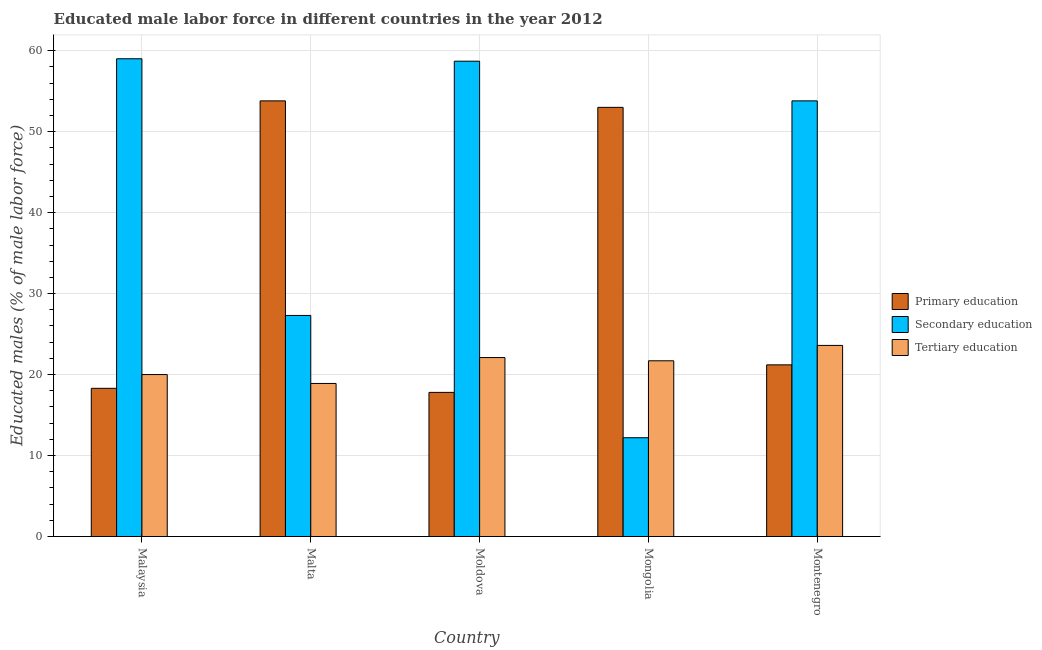How many different coloured bars are there?
Offer a very short reply. 3. How many groups of bars are there?
Give a very brief answer. 5. Are the number of bars per tick equal to the number of legend labels?
Make the answer very short. Yes. Are the number of bars on each tick of the X-axis equal?
Make the answer very short. Yes. How many bars are there on the 5th tick from the left?
Your answer should be compact. 3. What is the label of the 2nd group of bars from the left?
Provide a short and direct response. Malta. In how many cases, is the number of bars for a given country not equal to the number of legend labels?
Your answer should be very brief. 0. What is the percentage of male labor force who received primary education in Malta?
Your answer should be very brief. 53.8. Across all countries, what is the maximum percentage of male labor force who received primary education?
Your answer should be compact. 53.8. Across all countries, what is the minimum percentage of male labor force who received tertiary education?
Offer a very short reply. 18.9. In which country was the percentage of male labor force who received primary education maximum?
Offer a terse response. Malta. In which country was the percentage of male labor force who received tertiary education minimum?
Provide a short and direct response. Malta. What is the total percentage of male labor force who received secondary education in the graph?
Your answer should be compact. 211. What is the difference between the percentage of male labor force who received primary education in Malta and that in Mongolia?
Offer a terse response. 0.8. What is the difference between the percentage of male labor force who received primary education in Montenegro and the percentage of male labor force who received tertiary education in Mongolia?
Keep it short and to the point. -0.5. What is the average percentage of male labor force who received primary education per country?
Provide a succinct answer. 32.82. What is the difference between the percentage of male labor force who received tertiary education and percentage of male labor force who received secondary education in Montenegro?
Offer a very short reply. -30.2. In how many countries, is the percentage of male labor force who received primary education greater than 42 %?
Ensure brevity in your answer.  2. What is the ratio of the percentage of male labor force who received primary education in Moldova to that in Mongolia?
Your response must be concise. 0.34. Is the percentage of male labor force who received primary education in Malta less than that in Mongolia?
Keep it short and to the point. No. Is the difference between the percentage of male labor force who received primary education in Malta and Montenegro greater than the difference between the percentage of male labor force who received secondary education in Malta and Montenegro?
Provide a succinct answer. Yes. What is the difference between the highest and the second highest percentage of male labor force who received secondary education?
Your response must be concise. 0.3. What is the difference between the highest and the lowest percentage of male labor force who received primary education?
Your answer should be compact. 36. In how many countries, is the percentage of male labor force who received primary education greater than the average percentage of male labor force who received primary education taken over all countries?
Your answer should be very brief. 2. What does the 2nd bar from the left in Mongolia represents?
Your answer should be compact. Secondary education. What does the 2nd bar from the right in Mongolia represents?
Offer a terse response. Secondary education. How many countries are there in the graph?
Your answer should be compact. 5. What is the difference between two consecutive major ticks on the Y-axis?
Offer a very short reply. 10. Are the values on the major ticks of Y-axis written in scientific E-notation?
Your answer should be compact. No. Where does the legend appear in the graph?
Offer a very short reply. Center right. How are the legend labels stacked?
Provide a short and direct response. Vertical. What is the title of the graph?
Offer a terse response. Educated male labor force in different countries in the year 2012. What is the label or title of the Y-axis?
Provide a short and direct response. Educated males (% of male labor force). What is the Educated males (% of male labor force) of Primary education in Malaysia?
Make the answer very short. 18.3. What is the Educated males (% of male labor force) of Primary education in Malta?
Offer a terse response. 53.8. What is the Educated males (% of male labor force) of Secondary education in Malta?
Give a very brief answer. 27.3. What is the Educated males (% of male labor force) in Tertiary education in Malta?
Provide a short and direct response. 18.9. What is the Educated males (% of male labor force) in Primary education in Moldova?
Offer a terse response. 17.8. What is the Educated males (% of male labor force) of Secondary education in Moldova?
Offer a very short reply. 58.7. What is the Educated males (% of male labor force) of Tertiary education in Moldova?
Ensure brevity in your answer.  22.1. What is the Educated males (% of male labor force) in Secondary education in Mongolia?
Ensure brevity in your answer.  12.2. What is the Educated males (% of male labor force) of Tertiary education in Mongolia?
Offer a terse response. 21.7. What is the Educated males (% of male labor force) of Primary education in Montenegro?
Offer a very short reply. 21.2. What is the Educated males (% of male labor force) in Secondary education in Montenegro?
Your answer should be very brief. 53.8. What is the Educated males (% of male labor force) in Tertiary education in Montenegro?
Provide a succinct answer. 23.6. Across all countries, what is the maximum Educated males (% of male labor force) in Primary education?
Keep it short and to the point. 53.8. Across all countries, what is the maximum Educated males (% of male labor force) of Tertiary education?
Make the answer very short. 23.6. Across all countries, what is the minimum Educated males (% of male labor force) in Primary education?
Give a very brief answer. 17.8. Across all countries, what is the minimum Educated males (% of male labor force) in Secondary education?
Your response must be concise. 12.2. Across all countries, what is the minimum Educated males (% of male labor force) of Tertiary education?
Ensure brevity in your answer.  18.9. What is the total Educated males (% of male labor force) in Primary education in the graph?
Offer a terse response. 164.1. What is the total Educated males (% of male labor force) of Secondary education in the graph?
Your response must be concise. 211. What is the total Educated males (% of male labor force) of Tertiary education in the graph?
Your response must be concise. 106.3. What is the difference between the Educated males (% of male labor force) in Primary education in Malaysia and that in Malta?
Make the answer very short. -35.5. What is the difference between the Educated males (% of male labor force) of Secondary education in Malaysia and that in Malta?
Keep it short and to the point. 31.7. What is the difference between the Educated males (% of male labor force) of Primary education in Malaysia and that in Moldova?
Offer a very short reply. 0.5. What is the difference between the Educated males (% of male labor force) in Primary education in Malaysia and that in Mongolia?
Ensure brevity in your answer.  -34.7. What is the difference between the Educated males (% of male labor force) in Secondary education in Malaysia and that in Mongolia?
Make the answer very short. 46.8. What is the difference between the Educated males (% of male labor force) of Tertiary education in Malaysia and that in Mongolia?
Your response must be concise. -1.7. What is the difference between the Educated males (% of male labor force) in Primary education in Malaysia and that in Montenegro?
Offer a very short reply. -2.9. What is the difference between the Educated males (% of male labor force) of Secondary education in Malaysia and that in Montenegro?
Your response must be concise. 5.2. What is the difference between the Educated males (% of male labor force) in Secondary education in Malta and that in Moldova?
Provide a short and direct response. -31.4. What is the difference between the Educated males (% of male labor force) of Primary education in Malta and that in Mongolia?
Your response must be concise. 0.8. What is the difference between the Educated males (% of male labor force) of Tertiary education in Malta and that in Mongolia?
Make the answer very short. -2.8. What is the difference between the Educated males (% of male labor force) of Primary education in Malta and that in Montenegro?
Offer a terse response. 32.6. What is the difference between the Educated males (% of male labor force) of Secondary education in Malta and that in Montenegro?
Keep it short and to the point. -26.5. What is the difference between the Educated males (% of male labor force) of Tertiary education in Malta and that in Montenegro?
Ensure brevity in your answer.  -4.7. What is the difference between the Educated males (% of male labor force) in Primary education in Moldova and that in Mongolia?
Keep it short and to the point. -35.2. What is the difference between the Educated males (% of male labor force) in Secondary education in Moldova and that in Mongolia?
Offer a very short reply. 46.5. What is the difference between the Educated males (% of male labor force) in Tertiary education in Moldova and that in Mongolia?
Keep it short and to the point. 0.4. What is the difference between the Educated males (% of male labor force) of Primary education in Moldova and that in Montenegro?
Offer a terse response. -3.4. What is the difference between the Educated males (% of male labor force) in Tertiary education in Moldova and that in Montenegro?
Make the answer very short. -1.5. What is the difference between the Educated males (% of male labor force) in Primary education in Mongolia and that in Montenegro?
Give a very brief answer. 31.8. What is the difference between the Educated males (% of male labor force) of Secondary education in Mongolia and that in Montenegro?
Provide a short and direct response. -41.6. What is the difference between the Educated males (% of male labor force) of Secondary education in Malaysia and the Educated males (% of male labor force) of Tertiary education in Malta?
Offer a very short reply. 40.1. What is the difference between the Educated males (% of male labor force) of Primary education in Malaysia and the Educated males (% of male labor force) of Secondary education in Moldova?
Ensure brevity in your answer.  -40.4. What is the difference between the Educated males (% of male labor force) of Secondary education in Malaysia and the Educated males (% of male labor force) of Tertiary education in Moldova?
Ensure brevity in your answer.  36.9. What is the difference between the Educated males (% of male labor force) in Primary education in Malaysia and the Educated males (% of male labor force) in Tertiary education in Mongolia?
Give a very brief answer. -3.4. What is the difference between the Educated males (% of male labor force) in Secondary education in Malaysia and the Educated males (% of male labor force) in Tertiary education in Mongolia?
Offer a terse response. 37.3. What is the difference between the Educated males (% of male labor force) in Primary education in Malaysia and the Educated males (% of male labor force) in Secondary education in Montenegro?
Provide a short and direct response. -35.5. What is the difference between the Educated males (% of male labor force) of Secondary education in Malaysia and the Educated males (% of male labor force) of Tertiary education in Montenegro?
Provide a short and direct response. 35.4. What is the difference between the Educated males (% of male labor force) in Primary education in Malta and the Educated males (% of male labor force) in Tertiary education in Moldova?
Provide a succinct answer. 31.7. What is the difference between the Educated males (% of male labor force) of Secondary education in Malta and the Educated males (% of male labor force) of Tertiary education in Moldova?
Offer a terse response. 5.2. What is the difference between the Educated males (% of male labor force) of Primary education in Malta and the Educated males (% of male labor force) of Secondary education in Mongolia?
Ensure brevity in your answer.  41.6. What is the difference between the Educated males (% of male labor force) in Primary education in Malta and the Educated males (% of male labor force) in Tertiary education in Mongolia?
Ensure brevity in your answer.  32.1. What is the difference between the Educated males (% of male labor force) of Primary education in Malta and the Educated males (% of male labor force) of Secondary education in Montenegro?
Your answer should be very brief. 0. What is the difference between the Educated males (% of male labor force) of Primary education in Malta and the Educated males (% of male labor force) of Tertiary education in Montenegro?
Your response must be concise. 30.2. What is the difference between the Educated males (% of male labor force) of Primary education in Moldova and the Educated males (% of male labor force) of Secondary education in Mongolia?
Ensure brevity in your answer.  5.6. What is the difference between the Educated males (% of male labor force) in Primary education in Moldova and the Educated males (% of male labor force) in Tertiary education in Mongolia?
Your answer should be very brief. -3.9. What is the difference between the Educated males (% of male labor force) of Primary education in Moldova and the Educated males (% of male labor force) of Secondary education in Montenegro?
Your answer should be compact. -36. What is the difference between the Educated males (% of male labor force) of Primary education in Moldova and the Educated males (% of male labor force) of Tertiary education in Montenegro?
Keep it short and to the point. -5.8. What is the difference between the Educated males (% of male labor force) in Secondary education in Moldova and the Educated males (% of male labor force) in Tertiary education in Montenegro?
Ensure brevity in your answer.  35.1. What is the difference between the Educated males (% of male labor force) of Primary education in Mongolia and the Educated males (% of male labor force) of Tertiary education in Montenegro?
Provide a short and direct response. 29.4. What is the average Educated males (% of male labor force) of Primary education per country?
Offer a very short reply. 32.82. What is the average Educated males (% of male labor force) in Secondary education per country?
Your answer should be compact. 42.2. What is the average Educated males (% of male labor force) of Tertiary education per country?
Your answer should be compact. 21.26. What is the difference between the Educated males (% of male labor force) of Primary education and Educated males (% of male labor force) of Secondary education in Malaysia?
Your answer should be compact. -40.7. What is the difference between the Educated males (% of male labor force) in Primary education and Educated males (% of male labor force) in Tertiary education in Malaysia?
Your answer should be very brief. -1.7. What is the difference between the Educated males (% of male labor force) of Primary education and Educated males (% of male labor force) of Secondary education in Malta?
Your answer should be very brief. 26.5. What is the difference between the Educated males (% of male labor force) in Primary education and Educated males (% of male labor force) in Tertiary education in Malta?
Ensure brevity in your answer.  34.9. What is the difference between the Educated males (% of male labor force) in Secondary education and Educated males (% of male labor force) in Tertiary education in Malta?
Give a very brief answer. 8.4. What is the difference between the Educated males (% of male labor force) of Primary education and Educated males (% of male labor force) of Secondary education in Moldova?
Offer a terse response. -40.9. What is the difference between the Educated males (% of male labor force) in Primary education and Educated males (% of male labor force) in Tertiary education in Moldova?
Give a very brief answer. -4.3. What is the difference between the Educated males (% of male labor force) in Secondary education and Educated males (% of male labor force) in Tertiary education in Moldova?
Make the answer very short. 36.6. What is the difference between the Educated males (% of male labor force) in Primary education and Educated males (% of male labor force) in Secondary education in Mongolia?
Give a very brief answer. 40.8. What is the difference between the Educated males (% of male labor force) of Primary education and Educated males (% of male labor force) of Tertiary education in Mongolia?
Make the answer very short. 31.3. What is the difference between the Educated males (% of male labor force) in Primary education and Educated males (% of male labor force) in Secondary education in Montenegro?
Your answer should be very brief. -32.6. What is the difference between the Educated males (% of male labor force) of Secondary education and Educated males (% of male labor force) of Tertiary education in Montenegro?
Provide a short and direct response. 30.2. What is the ratio of the Educated males (% of male labor force) in Primary education in Malaysia to that in Malta?
Offer a very short reply. 0.34. What is the ratio of the Educated males (% of male labor force) in Secondary education in Malaysia to that in Malta?
Offer a terse response. 2.16. What is the ratio of the Educated males (% of male labor force) in Tertiary education in Malaysia to that in Malta?
Keep it short and to the point. 1.06. What is the ratio of the Educated males (% of male labor force) in Primary education in Malaysia to that in Moldova?
Your response must be concise. 1.03. What is the ratio of the Educated males (% of male labor force) of Tertiary education in Malaysia to that in Moldova?
Provide a short and direct response. 0.91. What is the ratio of the Educated males (% of male labor force) in Primary education in Malaysia to that in Mongolia?
Provide a succinct answer. 0.35. What is the ratio of the Educated males (% of male labor force) of Secondary education in Malaysia to that in Mongolia?
Offer a very short reply. 4.84. What is the ratio of the Educated males (% of male labor force) in Tertiary education in Malaysia to that in Mongolia?
Your response must be concise. 0.92. What is the ratio of the Educated males (% of male labor force) of Primary education in Malaysia to that in Montenegro?
Make the answer very short. 0.86. What is the ratio of the Educated males (% of male labor force) in Secondary education in Malaysia to that in Montenegro?
Give a very brief answer. 1.1. What is the ratio of the Educated males (% of male labor force) of Tertiary education in Malaysia to that in Montenegro?
Offer a terse response. 0.85. What is the ratio of the Educated males (% of male labor force) in Primary education in Malta to that in Moldova?
Ensure brevity in your answer.  3.02. What is the ratio of the Educated males (% of male labor force) in Secondary education in Malta to that in Moldova?
Provide a short and direct response. 0.47. What is the ratio of the Educated males (% of male labor force) in Tertiary education in Malta to that in Moldova?
Ensure brevity in your answer.  0.86. What is the ratio of the Educated males (% of male labor force) in Primary education in Malta to that in Mongolia?
Your answer should be compact. 1.02. What is the ratio of the Educated males (% of male labor force) of Secondary education in Malta to that in Mongolia?
Provide a succinct answer. 2.24. What is the ratio of the Educated males (% of male labor force) in Tertiary education in Malta to that in Mongolia?
Ensure brevity in your answer.  0.87. What is the ratio of the Educated males (% of male labor force) in Primary education in Malta to that in Montenegro?
Offer a very short reply. 2.54. What is the ratio of the Educated males (% of male labor force) of Secondary education in Malta to that in Montenegro?
Your answer should be compact. 0.51. What is the ratio of the Educated males (% of male labor force) of Tertiary education in Malta to that in Montenegro?
Your answer should be compact. 0.8. What is the ratio of the Educated males (% of male labor force) in Primary education in Moldova to that in Mongolia?
Provide a short and direct response. 0.34. What is the ratio of the Educated males (% of male labor force) of Secondary education in Moldova to that in Mongolia?
Your answer should be very brief. 4.81. What is the ratio of the Educated males (% of male labor force) of Tertiary education in Moldova to that in Mongolia?
Offer a terse response. 1.02. What is the ratio of the Educated males (% of male labor force) in Primary education in Moldova to that in Montenegro?
Provide a succinct answer. 0.84. What is the ratio of the Educated males (% of male labor force) in Secondary education in Moldova to that in Montenegro?
Your response must be concise. 1.09. What is the ratio of the Educated males (% of male labor force) in Tertiary education in Moldova to that in Montenegro?
Ensure brevity in your answer.  0.94. What is the ratio of the Educated males (% of male labor force) in Primary education in Mongolia to that in Montenegro?
Your response must be concise. 2.5. What is the ratio of the Educated males (% of male labor force) of Secondary education in Mongolia to that in Montenegro?
Your answer should be very brief. 0.23. What is the ratio of the Educated males (% of male labor force) of Tertiary education in Mongolia to that in Montenegro?
Keep it short and to the point. 0.92. What is the difference between the highest and the second highest Educated males (% of male labor force) of Primary education?
Ensure brevity in your answer.  0.8. What is the difference between the highest and the second highest Educated males (% of male labor force) in Secondary education?
Ensure brevity in your answer.  0.3. What is the difference between the highest and the lowest Educated males (% of male labor force) in Primary education?
Provide a succinct answer. 36. What is the difference between the highest and the lowest Educated males (% of male labor force) of Secondary education?
Offer a very short reply. 46.8. 